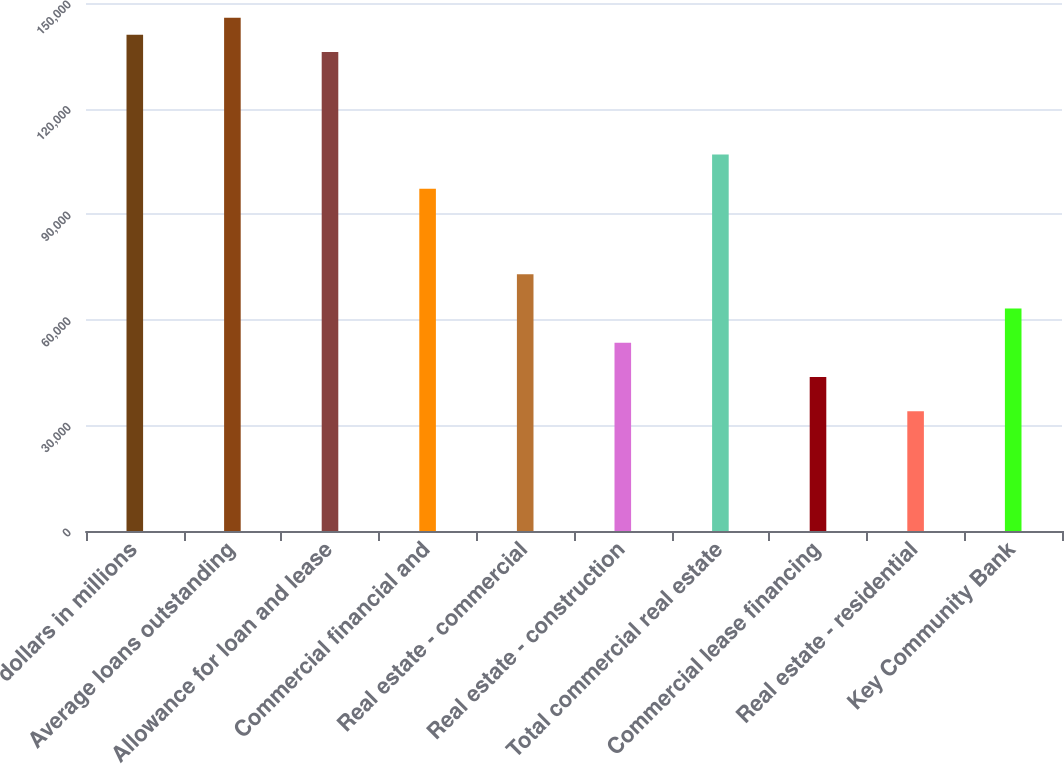Convert chart. <chart><loc_0><loc_0><loc_500><loc_500><bar_chart><fcel>dollars in millions<fcel>Average loans outstanding<fcel>Allowance for loan and lease<fcel>Commercial financial and<fcel>Real estate - commercial<fcel>Real estate - construction<fcel>Total commercial real estate<fcel>Commercial lease financing<fcel>Real estate - residential<fcel>Key Community Bank<nl><fcel>140955<fcel>145816<fcel>136095<fcel>97210.9<fcel>72908.5<fcel>53466.5<fcel>106932<fcel>43745.5<fcel>34024.5<fcel>63187.5<nl></chart> 